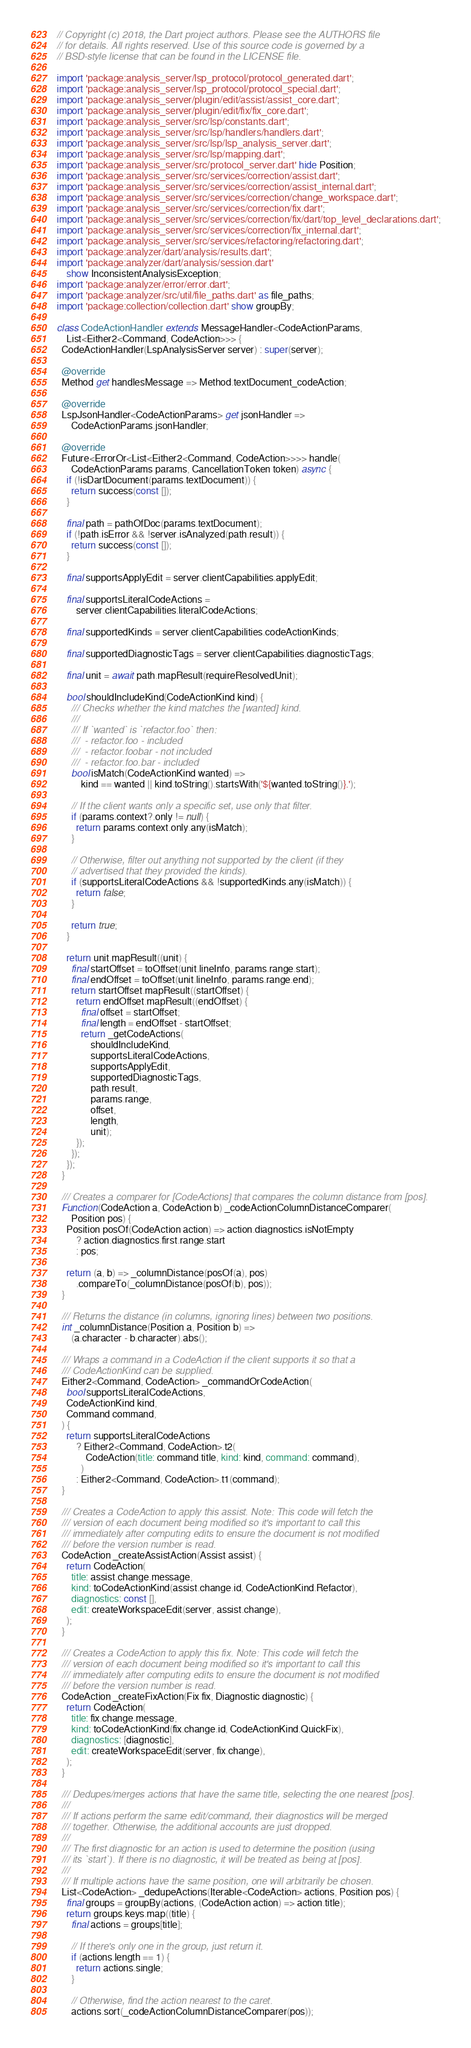Convert code to text. <code><loc_0><loc_0><loc_500><loc_500><_Dart_>// Copyright (c) 2018, the Dart project authors. Please see the AUTHORS file
// for details. All rights reserved. Use of this source code is governed by a
// BSD-style license that can be found in the LICENSE file.

import 'package:analysis_server/lsp_protocol/protocol_generated.dart';
import 'package:analysis_server/lsp_protocol/protocol_special.dart';
import 'package:analysis_server/plugin/edit/assist/assist_core.dart';
import 'package:analysis_server/plugin/edit/fix/fix_core.dart';
import 'package:analysis_server/src/lsp/constants.dart';
import 'package:analysis_server/src/lsp/handlers/handlers.dart';
import 'package:analysis_server/src/lsp/lsp_analysis_server.dart';
import 'package:analysis_server/src/lsp/mapping.dart';
import 'package:analysis_server/src/protocol_server.dart' hide Position;
import 'package:analysis_server/src/services/correction/assist.dart';
import 'package:analysis_server/src/services/correction/assist_internal.dart';
import 'package:analysis_server/src/services/correction/change_workspace.dart';
import 'package:analysis_server/src/services/correction/fix.dart';
import 'package:analysis_server/src/services/correction/fix/dart/top_level_declarations.dart';
import 'package:analysis_server/src/services/correction/fix_internal.dart';
import 'package:analysis_server/src/services/refactoring/refactoring.dart';
import 'package:analyzer/dart/analysis/results.dart';
import 'package:analyzer/dart/analysis/session.dart'
    show InconsistentAnalysisException;
import 'package:analyzer/error/error.dart';
import 'package:analyzer/src/util/file_paths.dart' as file_paths;
import 'package:collection/collection.dart' show groupBy;

class CodeActionHandler extends MessageHandler<CodeActionParams,
    List<Either2<Command, CodeAction>>> {
  CodeActionHandler(LspAnalysisServer server) : super(server);

  @override
  Method get handlesMessage => Method.textDocument_codeAction;

  @override
  LspJsonHandler<CodeActionParams> get jsonHandler =>
      CodeActionParams.jsonHandler;

  @override
  Future<ErrorOr<List<Either2<Command, CodeAction>>>> handle(
      CodeActionParams params, CancellationToken token) async {
    if (!isDartDocument(params.textDocument)) {
      return success(const []);
    }

    final path = pathOfDoc(params.textDocument);
    if (!path.isError && !server.isAnalyzed(path.result)) {
      return success(const []);
    }

    final supportsApplyEdit = server.clientCapabilities.applyEdit;

    final supportsLiteralCodeActions =
        server.clientCapabilities.literalCodeActions;

    final supportedKinds = server.clientCapabilities.codeActionKinds;

    final supportedDiagnosticTags = server.clientCapabilities.diagnosticTags;

    final unit = await path.mapResult(requireResolvedUnit);

    bool shouldIncludeKind(CodeActionKind kind) {
      /// Checks whether the kind matches the [wanted] kind.
      ///
      /// If `wanted` is `refactor.foo` then:
      ///  - refactor.foo - included
      ///  - refactor.foobar - not included
      ///  - refactor.foo.bar - included
      bool isMatch(CodeActionKind wanted) =>
          kind == wanted || kind.toString().startsWith('${wanted.toString()}.');

      // If the client wants only a specific set, use only that filter.
      if (params.context?.only != null) {
        return params.context.only.any(isMatch);
      }

      // Otherwise, filter out anything not supported by the client (if they
      // advertised that they provided the kinds).
      if (supportsLiteralCodeActions && !supportedKinds.any(isMatch)) {
        return false;
      }

      return true;
    }

    return unit.mapResult((unit) {
      final startOffset = toOffset(unit.lineInfo, params.range.start);
      final endOffset = toOffset(unit.lineInfo, params.range.end);
      return startOffset.mapResult((startOffset) {
        return endOffset.mapResult((endOffset) {
          final offset = startOffset;
          final length = endOffset - startOffset;
          return _getCodeActions(
              shouldIncludeKind,
              supportsLiteralCodeActions,
              supportsApplyEdit,
              supportedDiagnosticTags,
              path.result,
              params.range,
              offset,
              length,
              unit);
        });
      });
    });
  }

  /// Creates a comparer for [CodeActions] that compares the column distance from [pos].
  Function(CodeAction a, CodeAction b) _codeActionColumnDistanceComparer(
      Position pos) {
    Position posOf(CodeAction action) => action.diagnostics.isNotEmpty
        ? action.diagnostics.first.range.start
        : pos;

    return (a, b) => _columnDistance(posOf(a), pos)
        .compareTo(_columnDistance(posOf(b), pos));
  }

  /// Returns the distance (in columns, ignoring lines) between two positions.
  int _columnDistance(Position a, Position b) =>
      (a.character - b.character).abs();

  /// Wraps a command in a CodeAction if the client supports it so that a
  /// CodeActionKind can be supplied.
  Either2<Command, CodeAction> _commandOrCodeAction(
    bool supportsLiteralCodeActions,
    CodeActionKind kind,
    Command command,
  ) {
    return supportsLiteralCodeActions
        ? Either2<Command, CodeAction>.t2(
            CodeAction(title: command.title, kind: kind, command: command),
          )
        : Either2<Command, CodeAction>.t1(command);
  }

  /// Creates a CodeAction to apply this assist. Note: This code will fetch the
  /// version of each document being modified so it's important to call this
  /// immediately after computing edits to ensure the document is not modified
  /// before the version number is read.
  CodeAction _createAssistAction(Assist assist) {
    return CodeAction(
      title: assist.change.message,
      kind: toCodeActionKind(assist.change.id, CodeActionKind.Refactor),
      diagnostics: const [],
      edit: createWorkspaceEdit(server, assist.change),
    );
  }

  /// Creates a CodeAction to apply this fix. Note: This code will fetch the
  /// version of each document being modified so it's important to call this
  /// immediately after computing edits to ensure the document is not modified
  /// before the version number is read.
  CodeAction _createFixAction(Fix fix, Diagnostic diagnostic) {
    return CodeAction(
      title: fix.change.message,
      kind: toCodeActionKind(fix.change.id, CodeActionKind.QuickFix),
      diagnostics: [diagnostic],
      edit: createWorkspaceEdit(server, fix.change),
    );
  }

  /// Dedupes/merges actions that have the same title, selecting the one nearest [pos].
  ///
  /// If actions perform the same edit/command, their diagnostics will be merged
  /// together. Otherwise, the additional accounts are just dropped.
  ///
  /// The first diagnostic for an action is used to determine the position (using
  /// its `start`). If there is no diagnostic, it will be treated as being at [pos].
  ///
  /// If multiple actions have the same position, one will arbitrarily be chosen.
  List<CodeAction> _dedupeActions(Iterable<CodeAction> actions, Position pos) {
    final groups = groupBy(actions, (CodeAction action) => action.title);
    return groups.keys.map((title) {
      final actions = groups[title];

      // If there's only one in the group, just return it.
      if (actions.length == 1) {
        return actions.single;
      }

      // Otherwise, find the action nearest to the caret.
      actions.sort(_codeActionColumnDistanceComparer(pos));</code> 